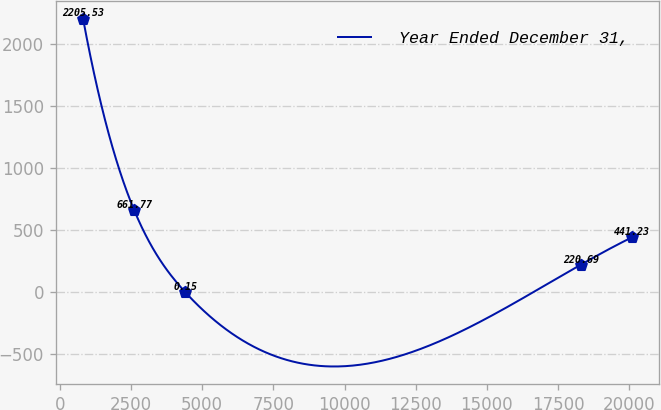Convert chart to OTSL. <chart><loc_0><loc_0><loc_500><loc_500><line_chart><ecel><fcel>Year Ended December 31,<nl><fcel>811.34<fcel>2205.53<nl><fcel>2606.95<fcel>661.77<nl><fcel>4402.56<fcel>0.15<nl><fcel>18297.4<fcel>220.69<nl><fcel>20093<fcel>441.23<nl></chart> 